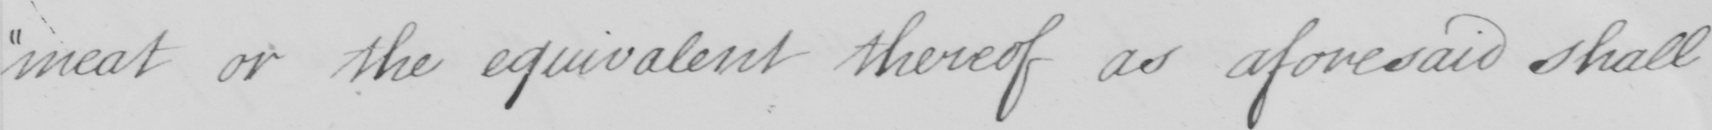Can you read and transcribe this handwriting? meat or the equivalent thereof as aforesaid shall 